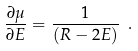Convert formula to latex. <formula><loc_0><loc_0><loc_500><loc_500>\frac { \partial \mu } { \partial E } = \frac { 1 } { ( R - 2 E ) } \ .</formula> 